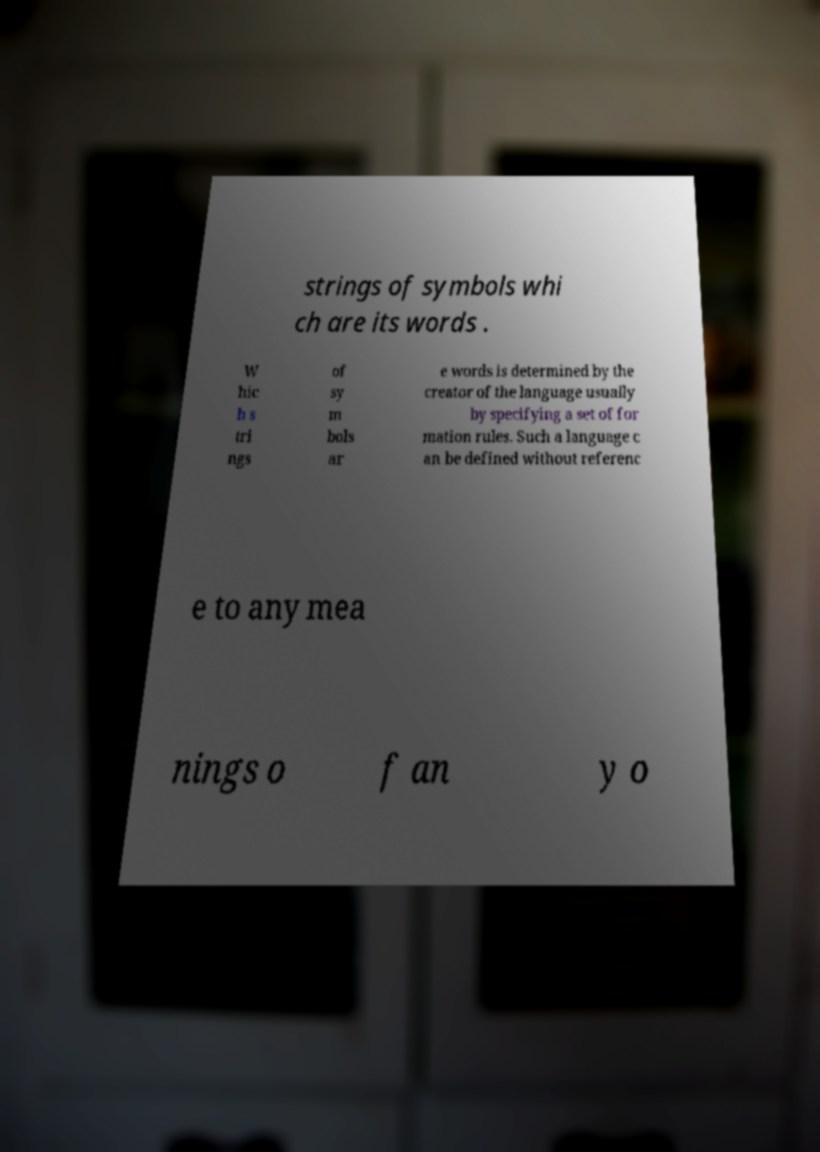Can you accurately transcribe the text from the provided image for me? strings of symbols whi ch are its words . W hic h s tri ngs of sy m bols ar e words is determined by the creator of the language usually by specifying a set of for mation rules. Such a language c an be defined without referenc e to any mea nings o f an y o 